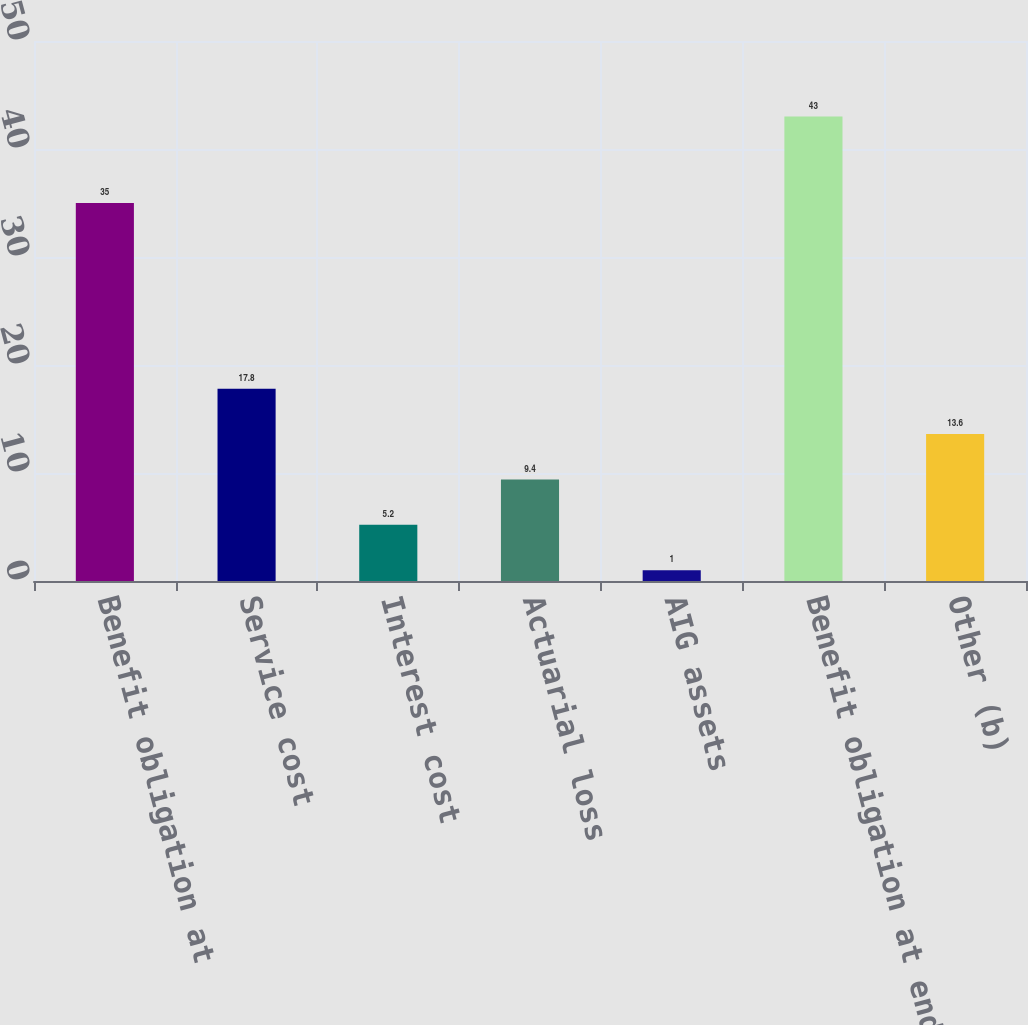Convert chart to OTSL. <chart><loc_0><loc_0><loc_500><loc_500><bar_chart><fcel>Benefit obligation at<fcel>Service cost<fcel>Interest cost<fcel>Actuarial loss<fcel>AIG assets<fcel>Benefit obligation at end of<fcel>Other (b)<nl><fcel>35<fcel>17.8<fcel>5.2<fcel>9.4<fcel>1<fcel>43<fcel>13.6<nl></chart> 